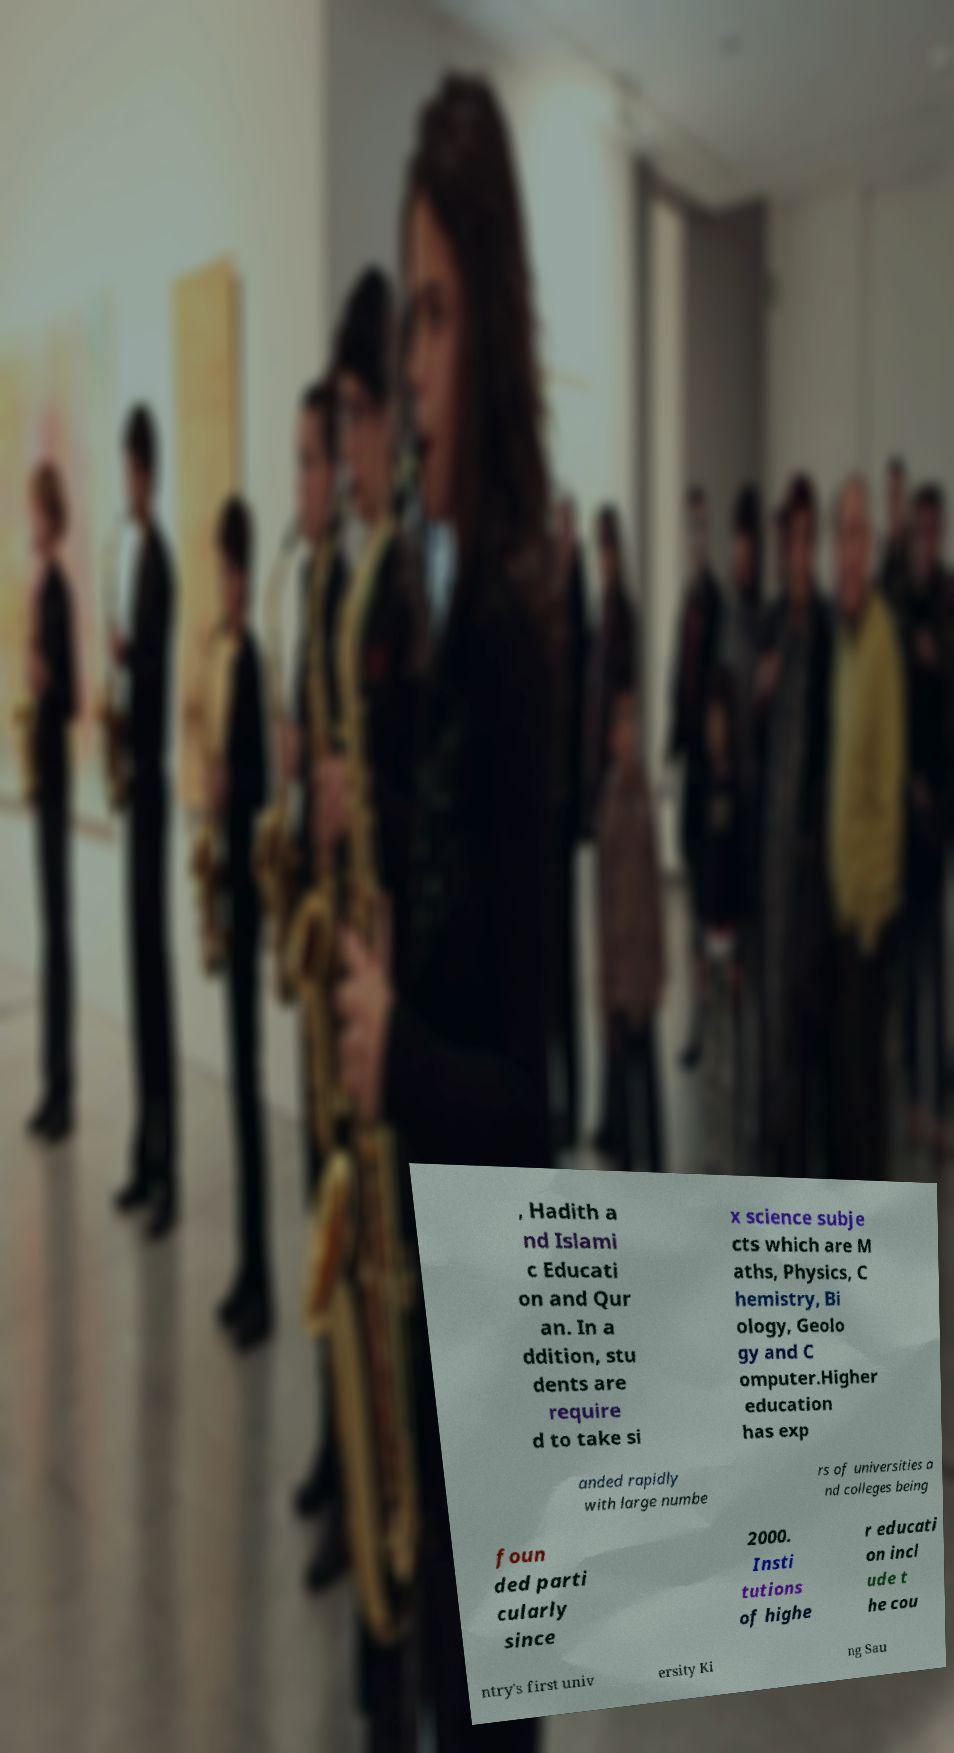Please read and relay the text visible in this image. What does it say? , Hadith a nd Islami c Educati on and Qur an. In a ddition, stu dents are require d to take si x science subje cts which are M aths, Physics, C hemistry, Bi ology, Geolo gy and C omputer.Higher education has exp anded rapidly with large numbe rs of universities a nd colleges being foun ded parti cularly since 2000. Insti tutions of highe r educati on incl ude t he cou ntry's first univ ersity Ki ng Sau 